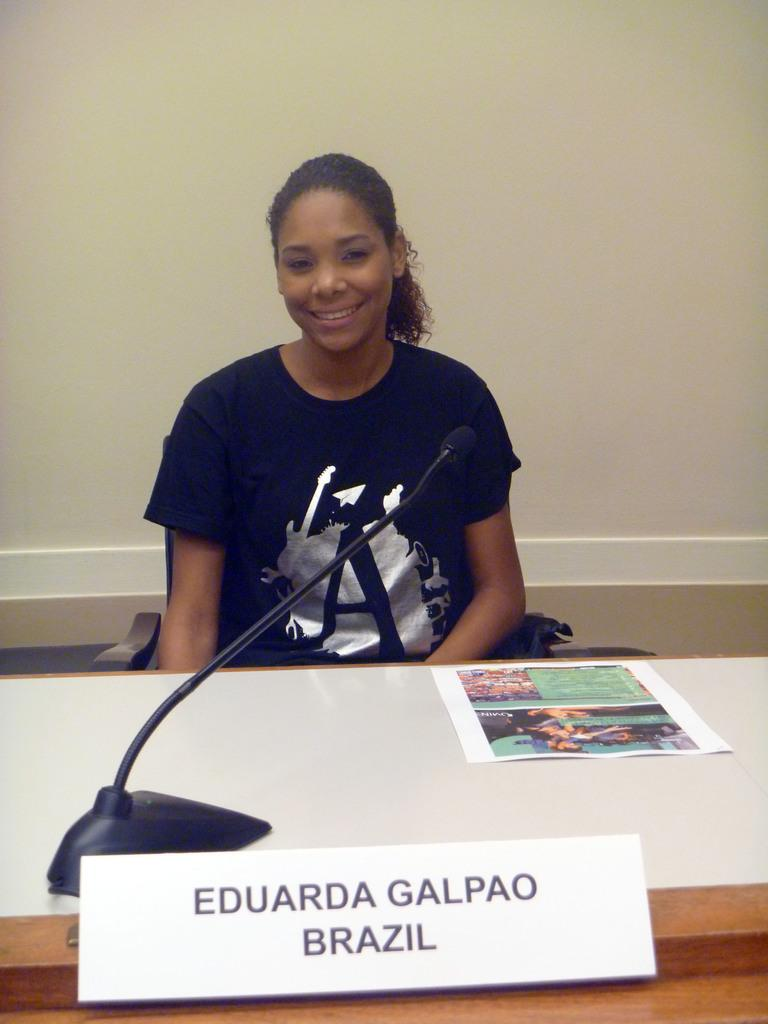What is the girl doing in the image? The girl is sitting in front of a table. What objects are on the table in the image? There is a paper, a microphone (mic), and a place card on the table. What can be seen in the background of the image? There is a wall in the background. What type of liquid is being poured from the box in the image? There is no liquid or box present in the image. 